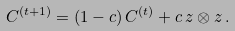Convert formula to latex. <formula><loc_0><loc_0><loc_500><loc_500>C ^ { ( t + 1 ) } = ( 1 - c ) \, C ^ { ( t ) } + c \, z \otimes z \, .</formula> 